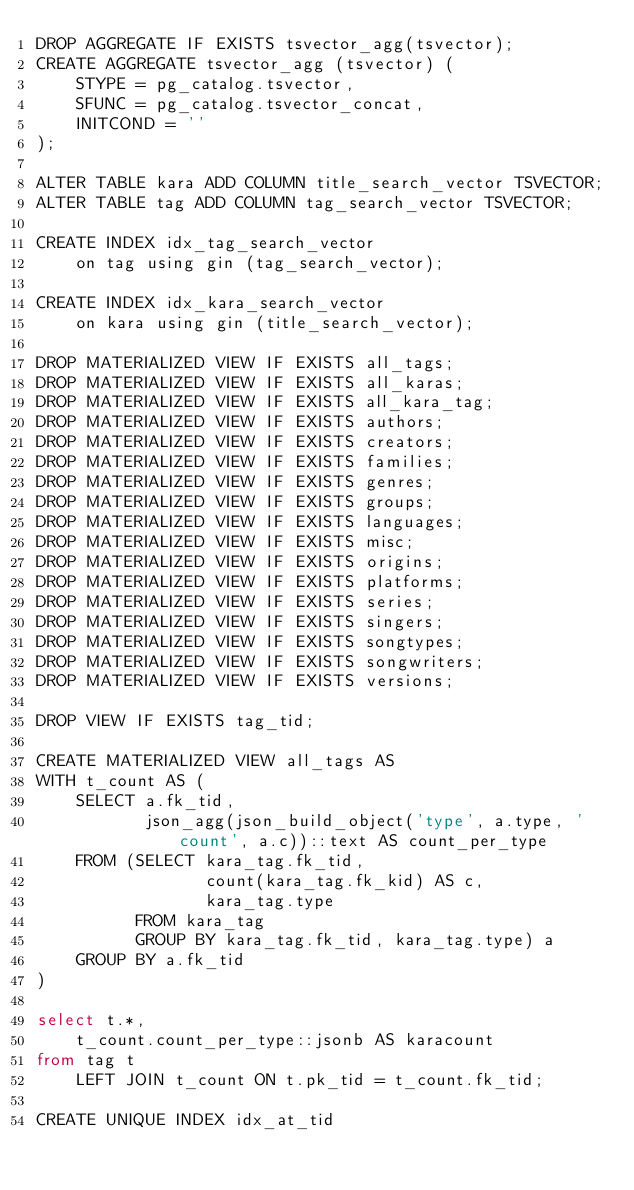Convert code to text. <code><loc_0><loc_0><loc_500><loc_500><_SQL_>DROP AGGREGATE IF EXISTS tsvector_agg(tsvector);
CREATE AGGREGATE tsvector_agg (tsvector) (
    STYPE = pg_catalog.tsvector,
    SFUNC = pg_catalog.tsvector_concat,
    INITCOND = ''
);

ALTER TABLE kara ADD COLUMN title_search_vector TSVECTOR;
ALTER TABLE tag ADD COLUMN tag_search_vector TSVECTOR;

CREATE INDEX idx_tag_search_vector
    on tag using gin (tag_search_vector);

CREATE INDEX idx_kara_search_vector
    on kara using gin (title_search_vector);

DROP MATERIALIZED VIEW IF EXISTS all_tags;
DROP MATERIALIZED VIEW IF EXISTS all_karas;
DROP MATERIALIZED VIEW IF EXISTS all_kara_tag;
DROP MATERIALIZED VIEW IF EXISTS authors;
DROP MATERIALIZED VIEW IF EXISTS creators;
DROP MATERIALIZED VIEW IF EXISTS families;
DROP MATERIALIZED VIEW IF EXISTS genres;
DROP MATERIALIZED VIEW IF EXISTS groups;
DROP MATERIALIZED VIEW IF EXISTS languages;
DROP MATERIALIZED VIEW IF EXISTS misc;
DROP MATERIALIZED VIEW IF EXISTS origins;
DROP MATERIALIZED VIEW IF EXISTS platforms;
DROP MATERIALIZED VIEW IF EXISTS series;
DROP MATERIALIZED VIEW IF EXISTS singers;
DROP MATERIALIZED VIEW IF EXISTS songtypes;
DROP MATERIALIZED VIEW IF EXISTS songwriters;
DROP MATERIALIZED VIEW IF EXISTS versions;

DROP VIEW IF EXISTS tag_tid;

CREATE MATERIALIZED VIEW all_tags AS
WITH t_count AS (
    SELECT a.fk_tid,
           json_agg(json_build_object('type', a.type, 'count', a.c))::text AS count_per_type
    FROM (SELECT kara_tag.fk_tid,
                 count(kara_tag.fk_kid) AS c,
                 kara_tag.type
          FROM kara_tag
          GROUP BY kara_tag.fk_tid, kara_tag.type) a
    GROUP BY a.fk_tid
)

select t.*,
	t_count.count_per_type::jsonb AS karacount
from tag t
	LEFT JOIN t_count ON t.pk_tid = t_count.fk_tid;

CREATE UNIQUE INDEX idx_at_tid</code> 